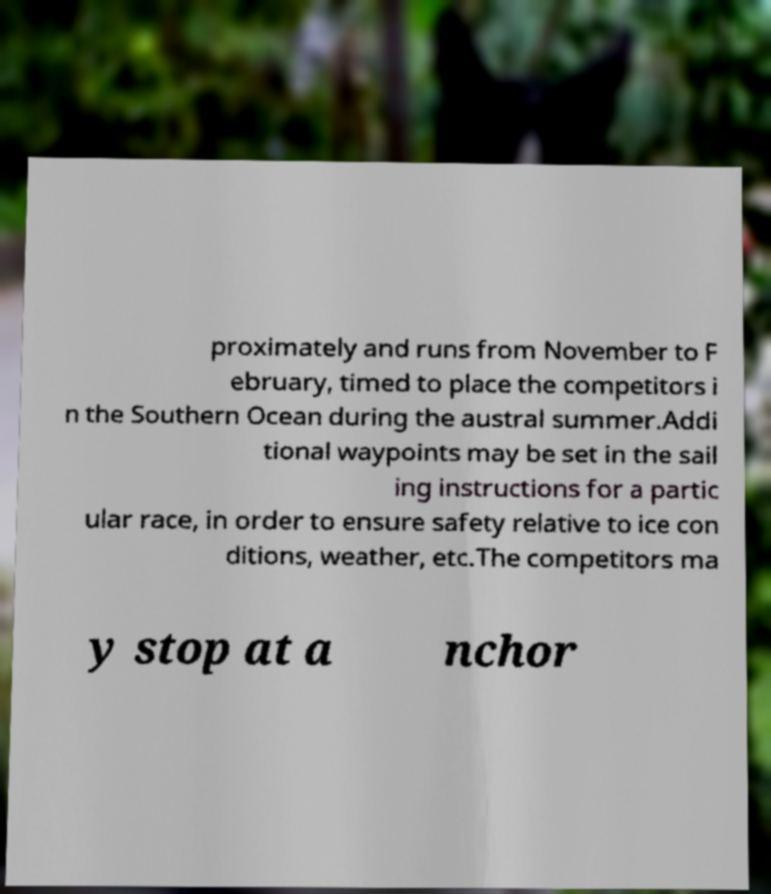Could you extract and type out the text from this image? proximately and runs from November to F ebruary, timed to place the competitors i n the Southern Ocean during the austral summer.Addi tional waypoints may be set in the sail ing instructions for a partic ular race, in order to ensure safety relative to ice con ditions, weather, etc.The competitors ma y stop at a nchor 